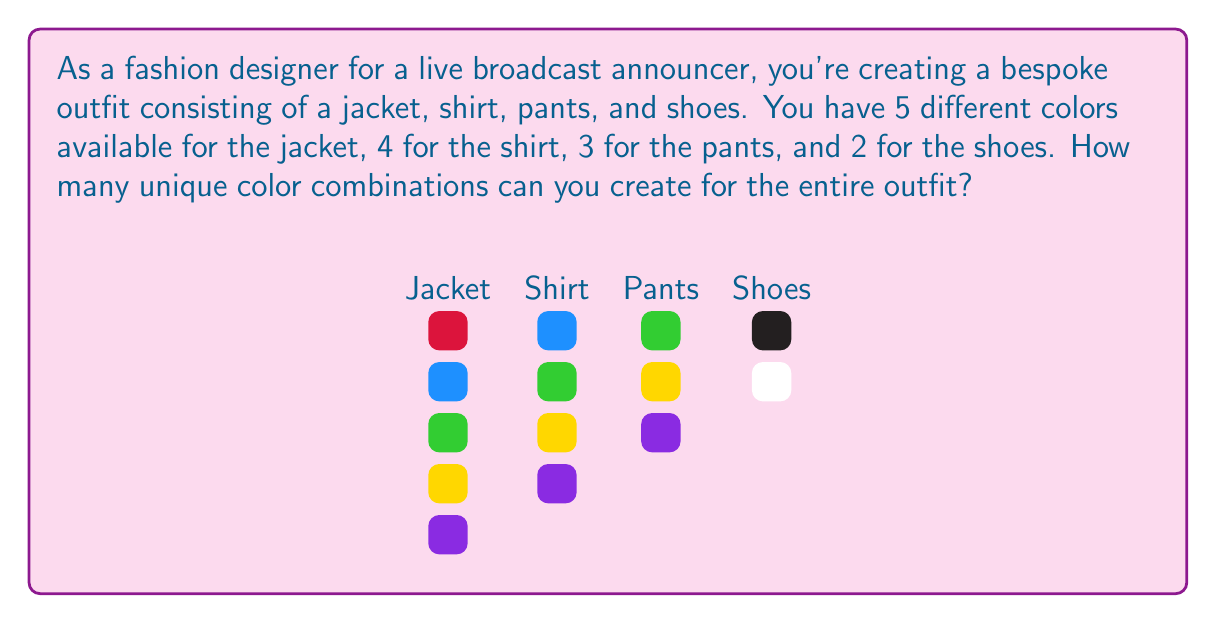Show me your answer to this math problem. To solve this problem, we need to use the multiplication principle of counting, which is a fundamental concept in permutations and combinations.

1) For each item of clothing, we have a certain number of color choices:
   - Jacket: 5 colors
   - Shirt: 4 colors
   - Pants: 3 colors
   - Shoes: 2 colors

2) For each complete outfit, we need to make one choice from each category. The total number of ways to do this is the product of the number of choices for each item.

3) We can represent this mathematically as:

   $$ \text{Total combinations} = 5 \times 4 \times 3 \times 2 $$

4) Let's calculate:
   $$ 5 \times 4 = 20 $$
   $$ 20 \times 3 = 60 $$
   $$ 60 \times 2 = 120 $$

5) Therefore, the total number of unique color combinations is 120.

This calculation represents a direct application of the fundamental counting principle, where the number of ways to perform a sequence of choices is the product of the number of ways to make each individual choice.
Answer: 120 combinations 